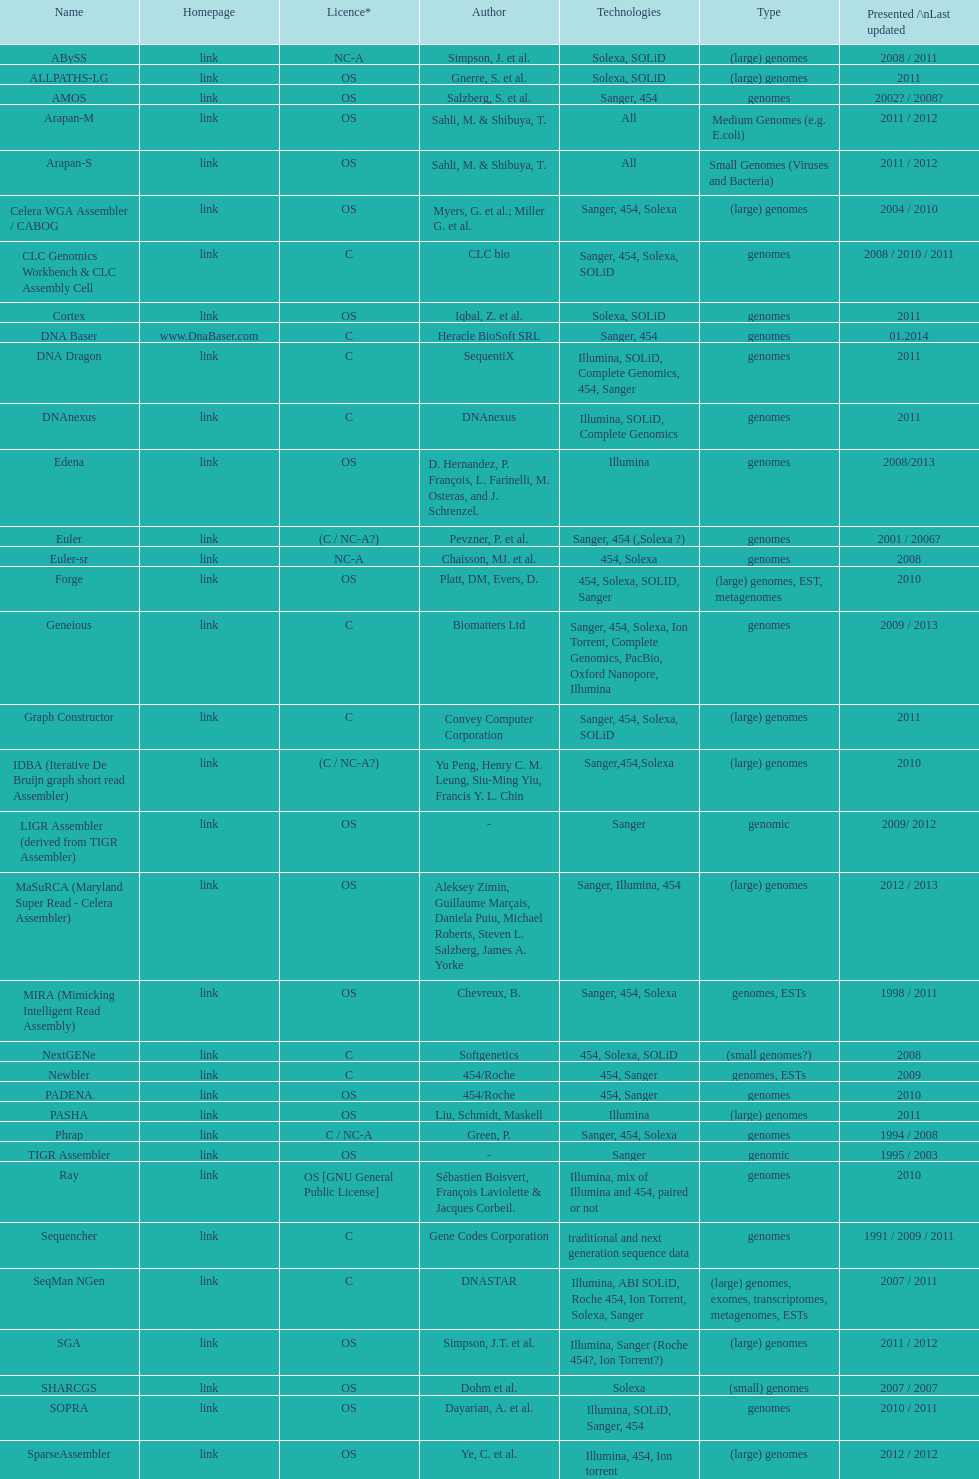Between os and c licenses, which one is mentioned more often? OS. 